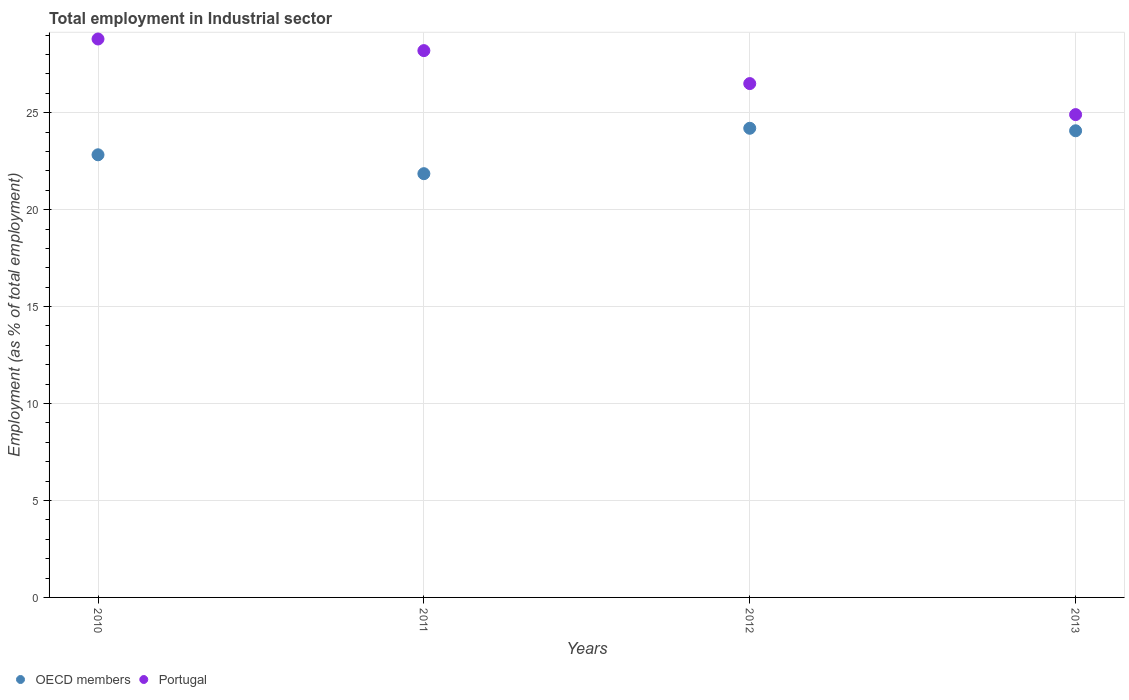How many different coloured dotlines are there?
Offer a terse response. 2. What is the employment in industrial sector in Portugal in 2011?
Your answer should be very brief. 28.2. Across all years, what is the maximum employment in industrial sector in OECD members?
Offer a terse response. 24.2. Across all years, what is the minimum employment in industrial sector in OECD members?
Offer a terse response. 21.85. What is the total employment in industrial sector in OECD members in the graph?
Offer a very short reply. 92.94. What is the difference between the employment in industrial sector in OECD members in 2012 and that in 2013?
Give a very brief answer. 0.13. What is the difference between the employment in industrial sector in OECD members in 2010 and the employment in industrial sector in Portugal in 2012?
Your answer should be very brief. -3.67. What is the average employment in industrial sector in OECD members per year?
Your response must be concise. 23.24. In the year 2010, what is the difference between the employment in industrial sector in OECD members and employment in industrial sector in Portugal?
Your answer should be very brief. -5.97. What is the ratio of the employment in industrial sector in OECD members in 2010 to that in 2011?
Keep it short and to the point. 1.04. What is the difference between the highest and the second highest employment in industrial sector in OECD members?
Offer a terse response. 0.13. What is the difference between the highest and the lowest employment in industrial sector in Portugal?
Provide a short and direct response. 3.9. Is the sum of the employment in industrial sector in OECD members in 2010 and 2012 greater than the maximum employment in industrial sector in Portugal across all years?
Give a very brief answer. Yes. Does the employment in industrial sector in OECD members monotonically increase over the years?
Make the answer very short. No. Is the employment in industrial sector in Portugal strictly less than the employment in industrial sector in OECD members over the years?
Ensure brevity in your answer.  No. How many dotlines are there?
Your response must be concise. 2. What is the difference between two consecutive major ticks on the Y-axis?
Offer a very short reply. 5. Does the graph contain grids?
Your response must be concise. Yes. What is the title of the graph?
Make the answer very short. Total employment in Industrial sector. Does "Turkmenistan" appear as one of the legend labels in the graph?
Your answer should be compact. No. What is the label or title of the X-axis?
Provide a short and direct response. Years. What is the label or title of the Y-axis?
Your answer should be compact. Employment (as % of total employment). What is the Employment (as % of total employment) in OECD members in 2010?
Provide a succinct answer. 22.83. What is the Employment (as % of total employment) of Portugal in 2010?
Keep it short and to the point. 28.8. What is the Employment (as % of total employment) in OECD members in 2011?
Keep it short and to the point. 21.85. What is the Employment (as % of total employment) in Portugal in 2011?
Offer a terse response. 28.2. What is the Employment (as % of total employment) in OECD members in 2012?
Make the answer very short. 24.2. What is the Employment (as % of total employment) of OECD members in 2013?
Your response must be concise. 24.07. What is the Employment (as % of total employment) in Portugal in 2013?
Give a very brief answer. 24.9. Across all years, what is the maximum Employment (as % of total employment) of OECD members?
Ensure brevity in your answer.  24.2. Across all years, what is the maximum Employment (as % of total employment) in Portugal?
Your answer should be compact. 28.8. Across all years, what is the minimum Employment (as % of total employment) of OECD members?
Your response must be concise. 21.85. Across all years, what is the minimum Employment (as % of total employment) in Portugal?
Keep it short and to the point. 24.9. What is the total Employment (as % of total employment) of OECD members in the graph?
Provide a short and direct response. 92.94. What is the total Employment (as % of total employment) in Portugal in the graph?
Offer a terse response. 108.4. What is the difference between the Employment (as % of total employment) in OECD members in 2010 and that in 2011?
Provide a succinct answer. 0.97. What is the difference between the Employment (as % of total employment) of Portugal in 2010 and that in 2011?
Your answer should be compact. 0.6. What is the difference between the Employment (as % of total employment) in OECD members in 2010 and that in 2012?
Offer a terse response. -1.37. What is the difference between the Employment (as % of total employment) in Portugal in 2010 and that in 2012?
Your answer should be compact. 2.3. What is the difference between the Employment (as % of total employment) of OECD members in 2010 and that in 2013?
Your answer should be very brief. -1.24. What is the difference between the Employment (as % of total employment) of Portugal in 2010 and that in 2013?
Provide a succinct answer. 3.9. What is the difference between the Employment (as % of total employment) of OECD members in 2011 and that in 2012?
Provide a short and direct response. -2.34. What is the difference between the Employment (as % of total employment) of OECD members in 2011 and that in 2013?
Offer a terse response. -2.21. What is the difference between the Employment (as % of total employment) in OECD members in 2012 and that in 2013?
Keep it short and to the point. 0.13. What is the difference between the Employment (as % of total employment) of Portugal in 2012 and that in 2013?
Give a very brief answer. 1.6. What is the difference between the Employment (as % of total employment) of OECD members in 2010 and the Employment (as % of total employment) of Portugal in 2011?
Your answer should be compact. -5.37. What is the difference between the Employment (as % of total employment) of OECD members in 2010 and the Employment (as % of total employment) of Portugal in 2012?
Offer a very short reply. -3.67. What is the difference between the Employment (as % of total employment) in OECD members in 2010 and the Employment (as % of total employment) in Portugal in 2013?
Provide a short and direct response. -2.07. What is the difference between the Employment (as % of total employment) of OECD members in 2011 and the Employment (as % of total employment) of Portugal in 2012?
Your response must be concise. -4.65. What is the difference between the Employment (as % of total employment) of OECD members in 2011 and the Employment (as % of total employment) of Portugal in 2013?
Your answer should be very brief. -3.05. What is the difference between the Employment (as % of total employment) of OECD members in 2012 and the Employment (as % of total employment) of Portugal in 2013?
Ensure brevity in your answer.  -0.7. What is the average Employment (as % of total employment) of OECD members per year?
Your answer should be compact. 23.24. What is the average Employment (as % of total employment) in Portugal per year?
Ensure brevity in your answer.  27.1. In the year 2010, what is the difference between the Employment (as % of total employment) of OECD members and Employment (as % of total employment) of Portugal?
Your answer should be compact. -5.97. In the year 2011, what is the difference between the Employment (as % of total employment) in OECD members and Employment (as % of total employment) in Portugal?
Make the answer very short. -6.35. In the year 2012, what is the difference between the Employment (as % of total employment) in OECD members and Employment (as % of total employment) in Portugal?
Your response must be concise. -2.3. In the year 2013, what is the difference between the Employment (as % of total employment) of OECD members and Employment (as % of total employment) of Portugal?
Provide a succinct answer. -0.83. What is the ratio of the Employment (as % of total employment) of OECD members in 2010 to that in 2011?
Offer a very short reply. 1.04. What is the ratio of the Employment (as % of total employment) in Portugal in 2010 to that in 2011?
Give a very brief answer. 1.02. What is the ratio of the Employment (as % of total employment) of OECD members in 2010 to that in 2012?
Give a very brief answer. 0.94. What is the ratio of the Employment (as % of total employment) of Portugal in 2010 to that in 2012?
Your response must be concise. 1.09. What is the ratio of the Employment (as % of total employment) of OECD members in 2010 to that in 2013?
Offer a very short reply. 0.95. What is the ratio of the Employment (as % of total employment) of Portugal in 2010 to that in 2013?
Provide a short and direct response. 1.16. What is the ratio of the Employment (as % of total employment) in OECD members in 2011 to that in 2012?
Your answer should be very brief. 0.9. What is the ratio of the Employment (as % of total employment) in Portugal in 2011 to that in 2012?
Make the answer very short. 1.06. What is the ratio of the Employment (as % of total employment) of OECD members in 2011 to that in 2013?
Keep it short and to the point. 0.91. What is the ratio of the Employment (as % of total employment) of Portugal in 2011 to that in 2013?
Provide a succinct answer. 1.13. What is the ratio of the Employment (as % of total employment) in OECD members in 2012 to that in 2013?
Offer a terse response. 1.01. What is the ratio of the Employment (as % of total employment) of Portugal in 2012 to that in 2013?
Offer a very short reply. 1.06. What is the difference between the highest and the second highest Employment (as % of total employment) in OECD members?
Keep it short and to the point. 0.13. What is the difference between the highest and the second highest Employment (as % of total employment) of Portugal?
Your answer should be compact. 0.6. What is the difference between the highest and the lowest Employment (as % of total employment) in OECD members?
Give a very brief answer. 2.34. 